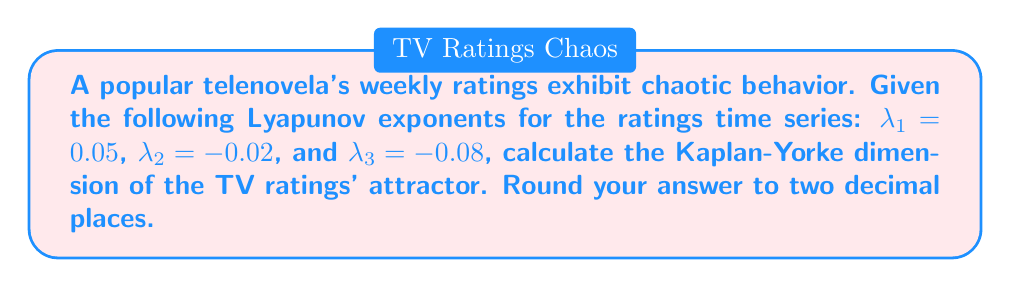Solve this math problem. To solve this problem, we'll follow these steps:

1. Recall the Kaplan-Yorke dimension formula:
   $$D_{KY} = j + \frac{\sum_{i=1}^j \lambda_i}{|\lambda_{j+1}|}$$
   where $j$ is the largest integer such that $\sum_{i=1}^j \lambda_i \geq 0$.

2. Order the Lyapunov exponents from largest to smallest:
   $\lambda_1 = 0.05$, $\lambda_2 = -0.02$, $\lambda_3 = -0.08$

3. Find $j$ by summing the exponents until the sum becomes negative:
   $\lambda_1 = 0.05 > 0$
   $\lambda_1 + \lambda_2 = 0.05 + (-0.02) = 0.03 > 0$
   $\lambda_1 + \lambda_2 + \lambda_3 = 0.05 + (-0.02) + (-0.08) = -0.05 < 0$
   Therefore, $j = 2$

4. Calculate the sum of the first $j$ exponents:
   $\sum_{i=1}^j \lambda_i = \lambda_1 + \lambda_2 = 0.05 + (-0.02) = 0.03$

5. Identify $|\lambda_{j+1}|$:
   $|\lambda_3| = |-0.08| = 0.08$

6. Apply the Kaplan-Yorke dimension formula:
   $$D_{KY} = 2 + \frac{0.03}{0.08} = 2 + 0.375 = 2.375$$

7. Round the result to two decimal places:
   $D_{KY} ≈ 2.38$
Answer: 2.38 